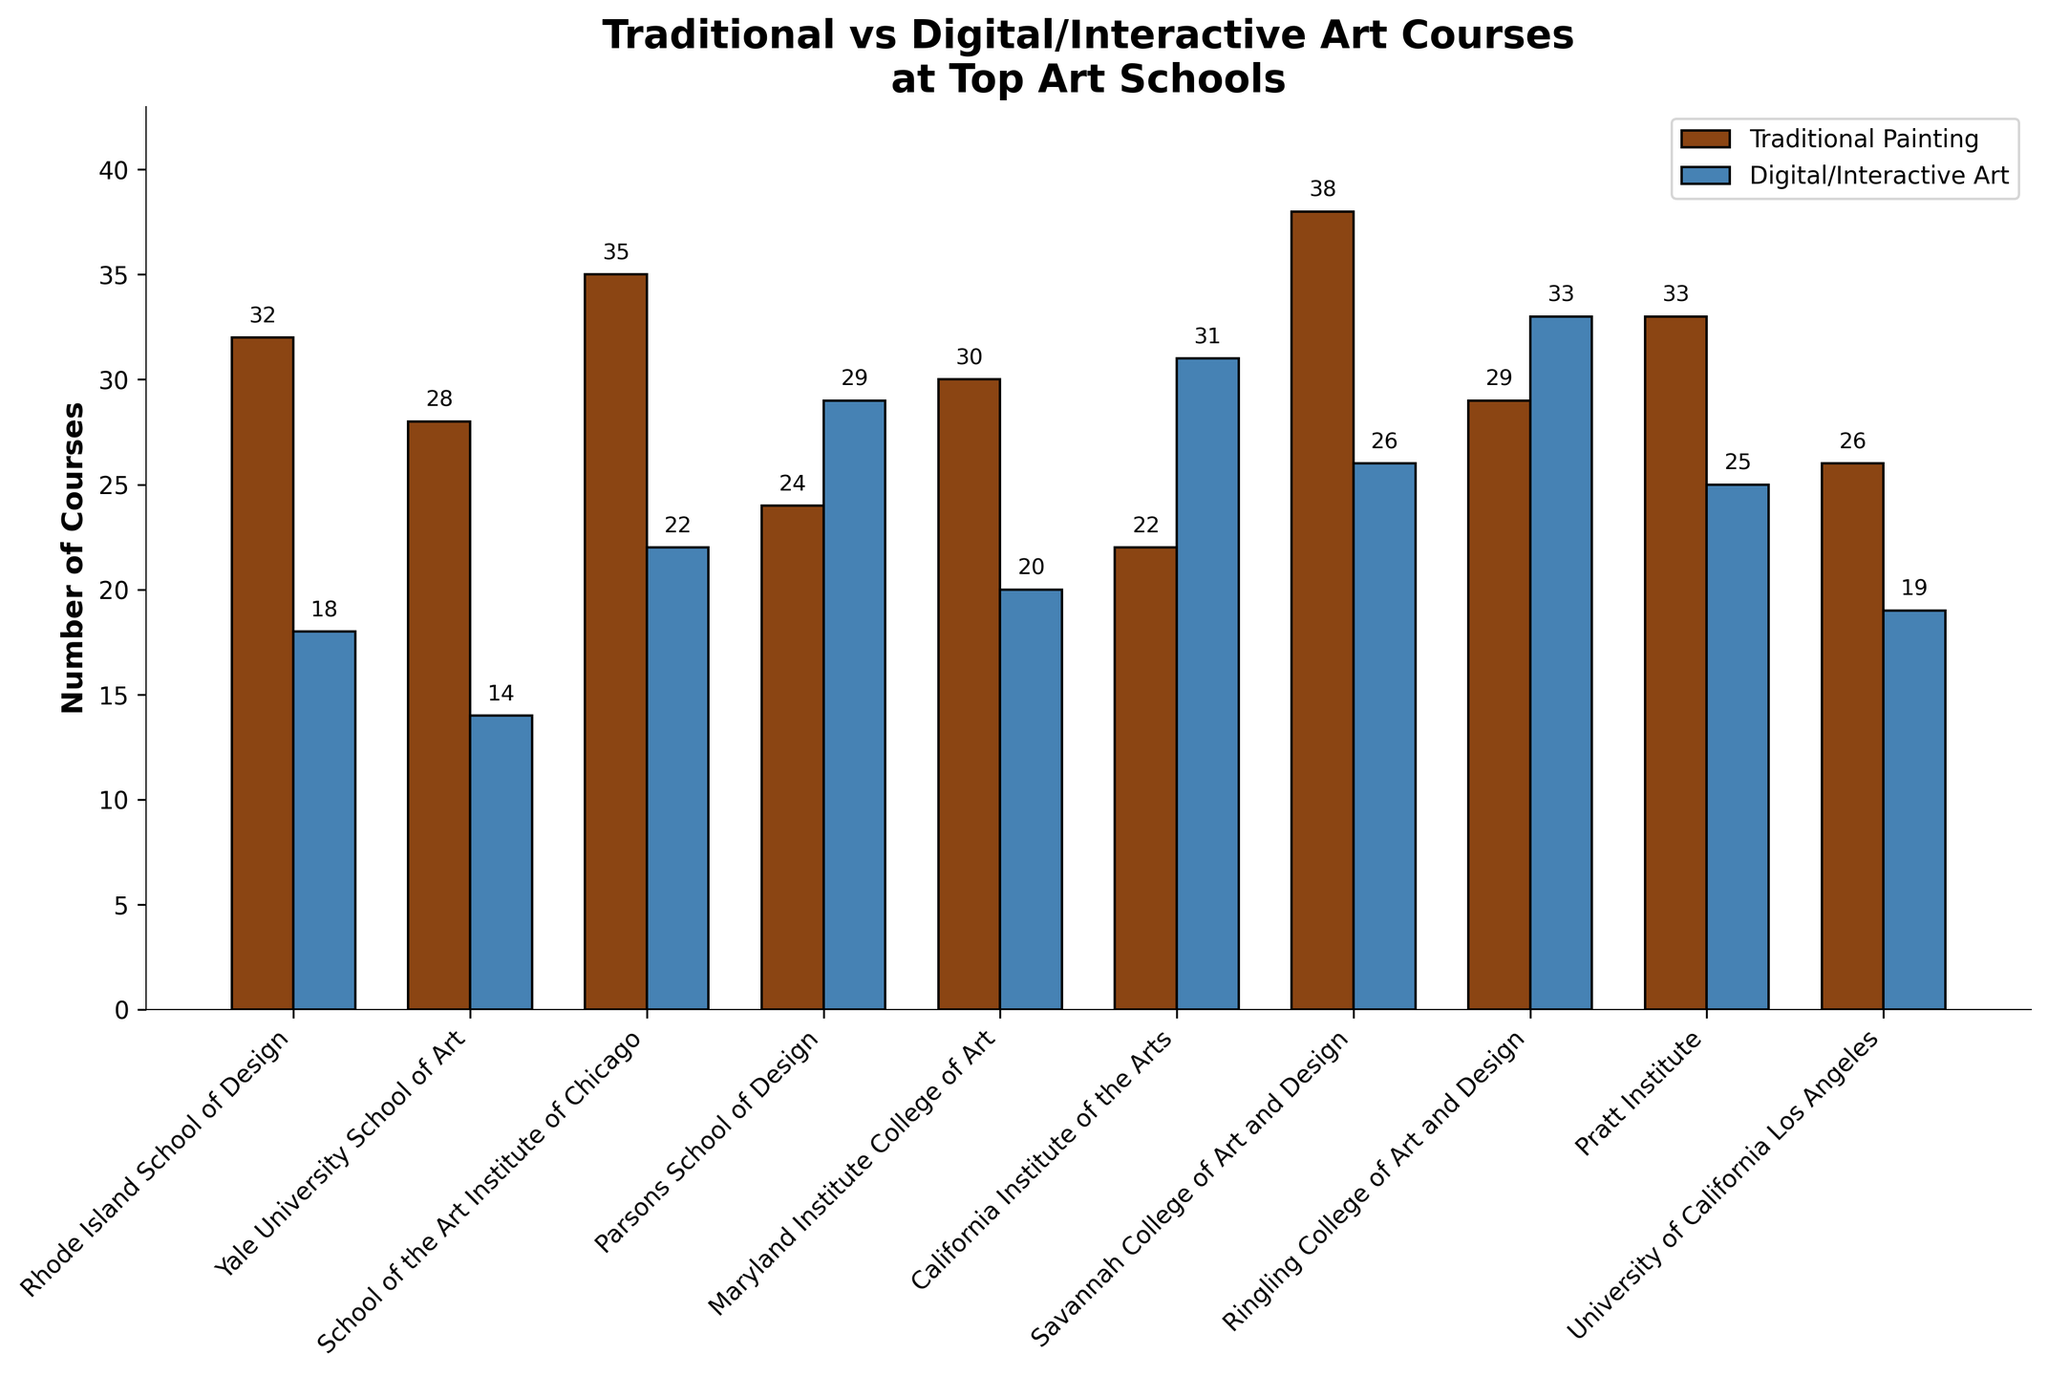Which school offers the most courses in Traditional Painting? By looking at the height of the bars, we can see that Savannah College of Art and Design has the tallest bar for Traditional Painting. Thus, it offers the most courses.
Answer: Savannah College of Art and Design Which school offers more Digital/Interactive Art Courses: Parsons School of Design or California Institute of the Arts? Comparing the height of the respective bars for Parsons School of Design and California Institute of the Arts, we see that California Institute of the Arts has a slightly taller bar.
Answer: California Institute of the Arts What is the total number of Traditional Painting Courses offered by all the schools combined? We add up all the numbers in the 'Traditional Painting Courses' column: 32 + 28 + 35 + 24 + 30 + 22 + 38 + 29 + 33 + 26 = 297.
Answer: 297 Which school has more balance in its offerings, Pratt Institute or Ringling College of Art and Design, based on the difference between Traditional Painting Courses and Digital/Interactive Art Courses? Pratt Institute has a difference of 33 - 25 = 8. Ringling College of Art and Design has a difference of 29 - 33 = -4. The smaller the absolute value of the difference, the more balanced the offerings. So, Pratt Institute is more balanced.
Answer: Pratt Institute Which school offers the fewest courses in Traditional Painting? By looking at the shortest bar in the Traditional Painting Courses category, California Institute of the Arts offers the fewest courses.
Answer: California Institute of the Arts How does the number of Traditional Painting Courses at Yale University School of Art compare to Savannah College of Art and Design? Yale University School of Art offers 28 courses while Savannah College of Art and Design offers 38. Comparing the numbers, Yale offers fewer courses.
Answer: Fewer Is the number of Digital/Interactive Art Courses offered at Ringling College of Art and Design greater than 30? By checking the height of the bar for Ringling College of Art and Design in Digital/Interactive Art Courses, it is clear the bar is slightly above 30.
Answer: Yes What's the average number of Digital/Interactive Art Courses offered at these top art schools? We sum up the numbers in 'Digital/Interactive Art Courses’, then divide by the number of schools: (18 + 14 + 22 + 29 + 20 + 31 + 26 + 33 + 25 + 19) / 10 = 237 / 10 = 23.7.
Answer: 23.7 